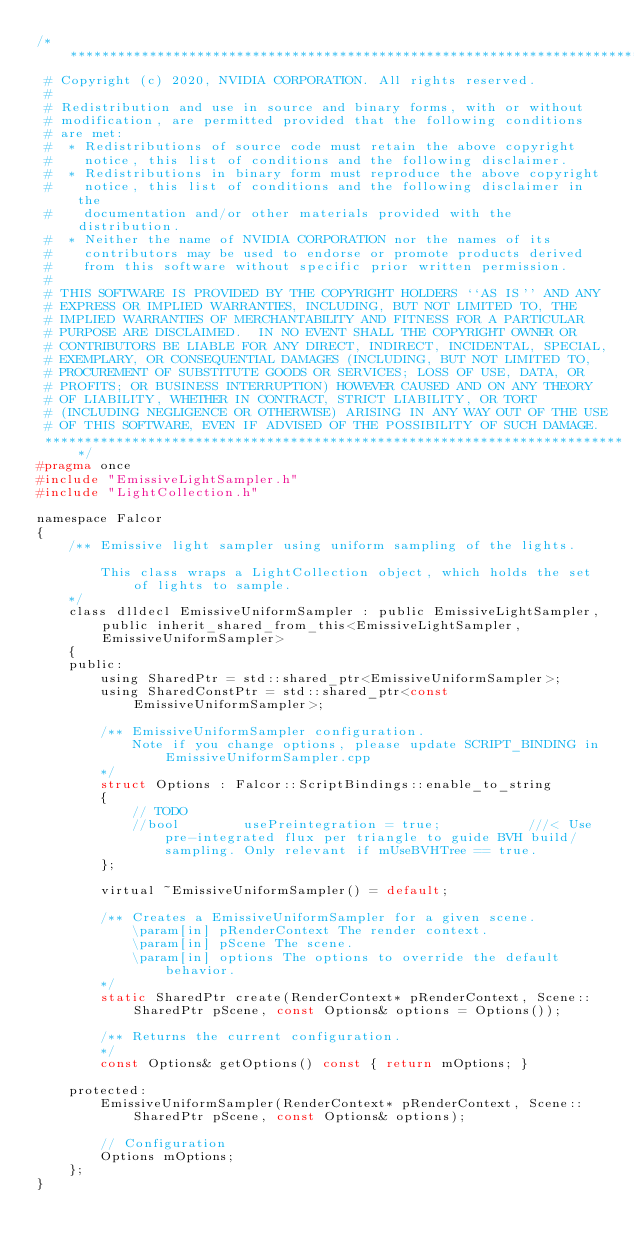<code> <loc_0><loc_0><loc_500><loc_500><_C_>/***************************************************************************
 # Copyright (c) 2020, NVIDIA CORPORATION. All rights reserved.
 #
 # Redistribution and use in source and binary forms, with or without
 # modification, are permitted provided that the following conditions
 # are met:
 #  * Redistributions of source code must retain the above copyright
 #    notice, this list of conditions and the following disclaimer.
 #  * Redistributions in binary form must reproduce the above copyright
 #    notice, this list of conditions and the following disclaimer in the
 #    documentation and/or other materials provided with the distribution.
 #  * Neither the name of NVIDIA CORPORATION nor the names of its
 #    contributors may be used to endorse or promote products derived
 #    from this software without specific prior written permission.
 #
 # THIS SOFTWARE IS PROVIDED BY THE COPYRIGHT HOLDERS ``AS IS'' AND ANY
 # EXPRESS OR IMPLIED WARRANTIES, INCLUDING, BUT NOT LIMITED TO, THE
 # IMPLIED WARRANTIES OF MERCHANTABILITY AND FITNESS FOR A PARTICULAR
 # PURPOSE ARE DISCLAIMED.  IN NO EVENT SHALL THE COPYRIGHT OWNER OR
 # CONTRIBUTORS BE LIABLE FOR ANY DIRECT, INDIRECT, INCIDENTAL, SPECIAL,
 # EXEMPLARY, OR CONSEQUENTIAL DAMAGES (INCLUDING, BUT NOT LIMITED TO,
 # PROCUREMENT OF SUBSTITUTE GOODS OR SERVICES; LOSS OF USE, DATA, OR
 # PROFITS; OR BUSINESS INTERRUPTION) HOWEVER CAUSED AND ON ANY THEORY
 # OF LIABILITY, WHETHER IN CONTRACT, STRICT LIABILITY, OR TORT
 # (INCLUDING NEGLIGENCE OR OTHERWISE) ARISING IN ANY WAY OUT OF THE USE
 # OF THIS SOFTWARE, EVEN IF ADVISED OF THE POSSIBILITY OF SUCH DAMAGE.
 **************************************************************************/
#pragma once
#include "EmissiveLightSampler.h"
#include "LightCollection.h"

namespace Falcor
{
    /** Emissive light sampler using uniform sampling of the lights.

        This class wraps a LightCollection object, which holds the set of lights to sample.
    */
    class dlldecl EmissiveUniformSampler : public EmissiveLightSampler, public inherit_shared_from_this<EmissiveLightSampler, EmissiveUniformSampler>
    {
    public:
        using SharedPtr = std::shared_ptr<EmissiveUniformSampler>;
        using SharedConstPtr = std::shared_ptr<const EmissiveUniformSampler>;

        /** EmissiveUniformSampler configuration.
            Note if you change options, please update SCRIPT_BINDING in EmissiveUniformSampler.cpp
        */
        struct Options : Falcor::ScriptBindings::enable_to_string
        {
            // TODO
            //bool        usePreintegration = true;           ///< Use pre-integrated flux per triangle to guide BVH build/sampling. Only relevant if mUseBVHTree == true.
        };

        virtual ~EmissiveUniformSampler() = default;

        /** Creates a EmissiveUniformSampler for a given scene.
            \param[in] pRenderContext The render context.
            \param[in] pScene The scene.
            \param[in] options The options to override the default behavior.
        */
        static SharedPtr create(RenderContext* pRenderContext, Scene::SharedPtr pScene, const Options& options = Options());

        /** Returns the current configuration.
        */
        const Options& getOptions() const { return mOptions; }

    protected:
        EmissiveUniformSampler(RenderContext* pRenderContext, Scene::SharedPtr pScene, const Options& options);

        // Configuration
        Options mOptions;
    };
}
</code> 